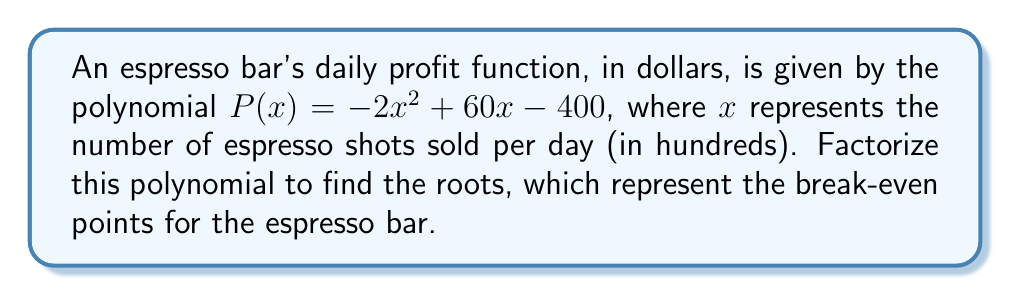Provide a solution to this math problem. To factorize the polynomial $P(x) = -2x^2 + 60x - 400$, we'll follow these steps:

1) First, let's identify the coefficients:
   $a = -2$, $b = 60$, and $c = -400$

2) We'll use the quadratic formula: $x = \frac{-b \pm \sqrt{b^2 - 4ac}}{2a}$

3) Substituting our values:
   $x = \frac{-60 \pm \sqrt{60^2 - 4(-2)(-400)}}{2(-2)}$

4) Simplify under the square root:
   $x = \frac{-60 \pm \sqrt{3600 - 3200}}{-4}$
   $x = \frac{-60 \pm \sqrt{400}}{-4}$
   $x = \frac{-60 \pm 20}{-4}$

5) This gives us two solutions:
   $x_1 = \frac{-60 + 20}{-4} = \frac{-40}{-4} = 10$
   $x_2 = \frac{-60 - 20}{-4} = \frac{-80}{-4} = 20$

6) Therefore, we can factorize the polynomial as:
   $P(x) = -2(x - 10)(x - 20)$

This factorization shows that the break-even points occur when the espresso bar sells 1000 (10 × 100) or 2000 (20 × 100) shots per day.
Answer: $P(x) = -2(x - 10)(x - 20)$ 